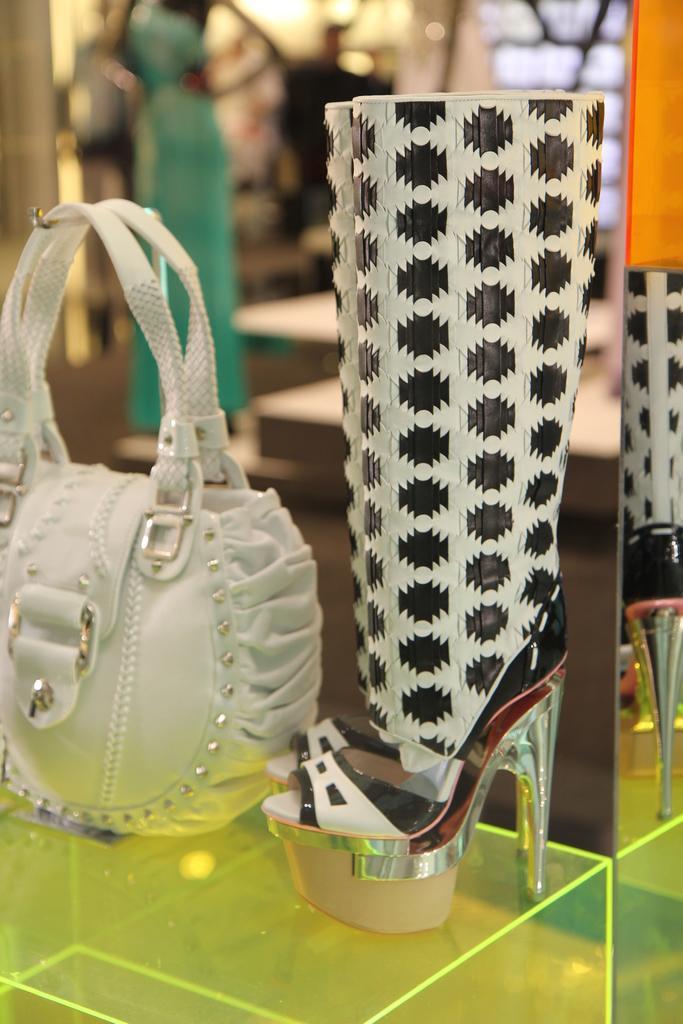How would you summarize this image in a sentence or two? In this picture there is a handbag , sandals on the table. 